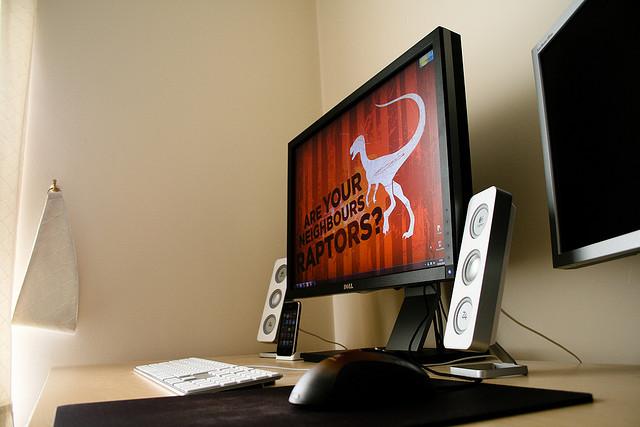Is there a dinosaur on the TV?
Give a very brief answer. Yes. What does it say on the TV?
Write a very short answer. Are your neighbors raptors?. What kind of electronic is this?
Concise answer only. Computer. 